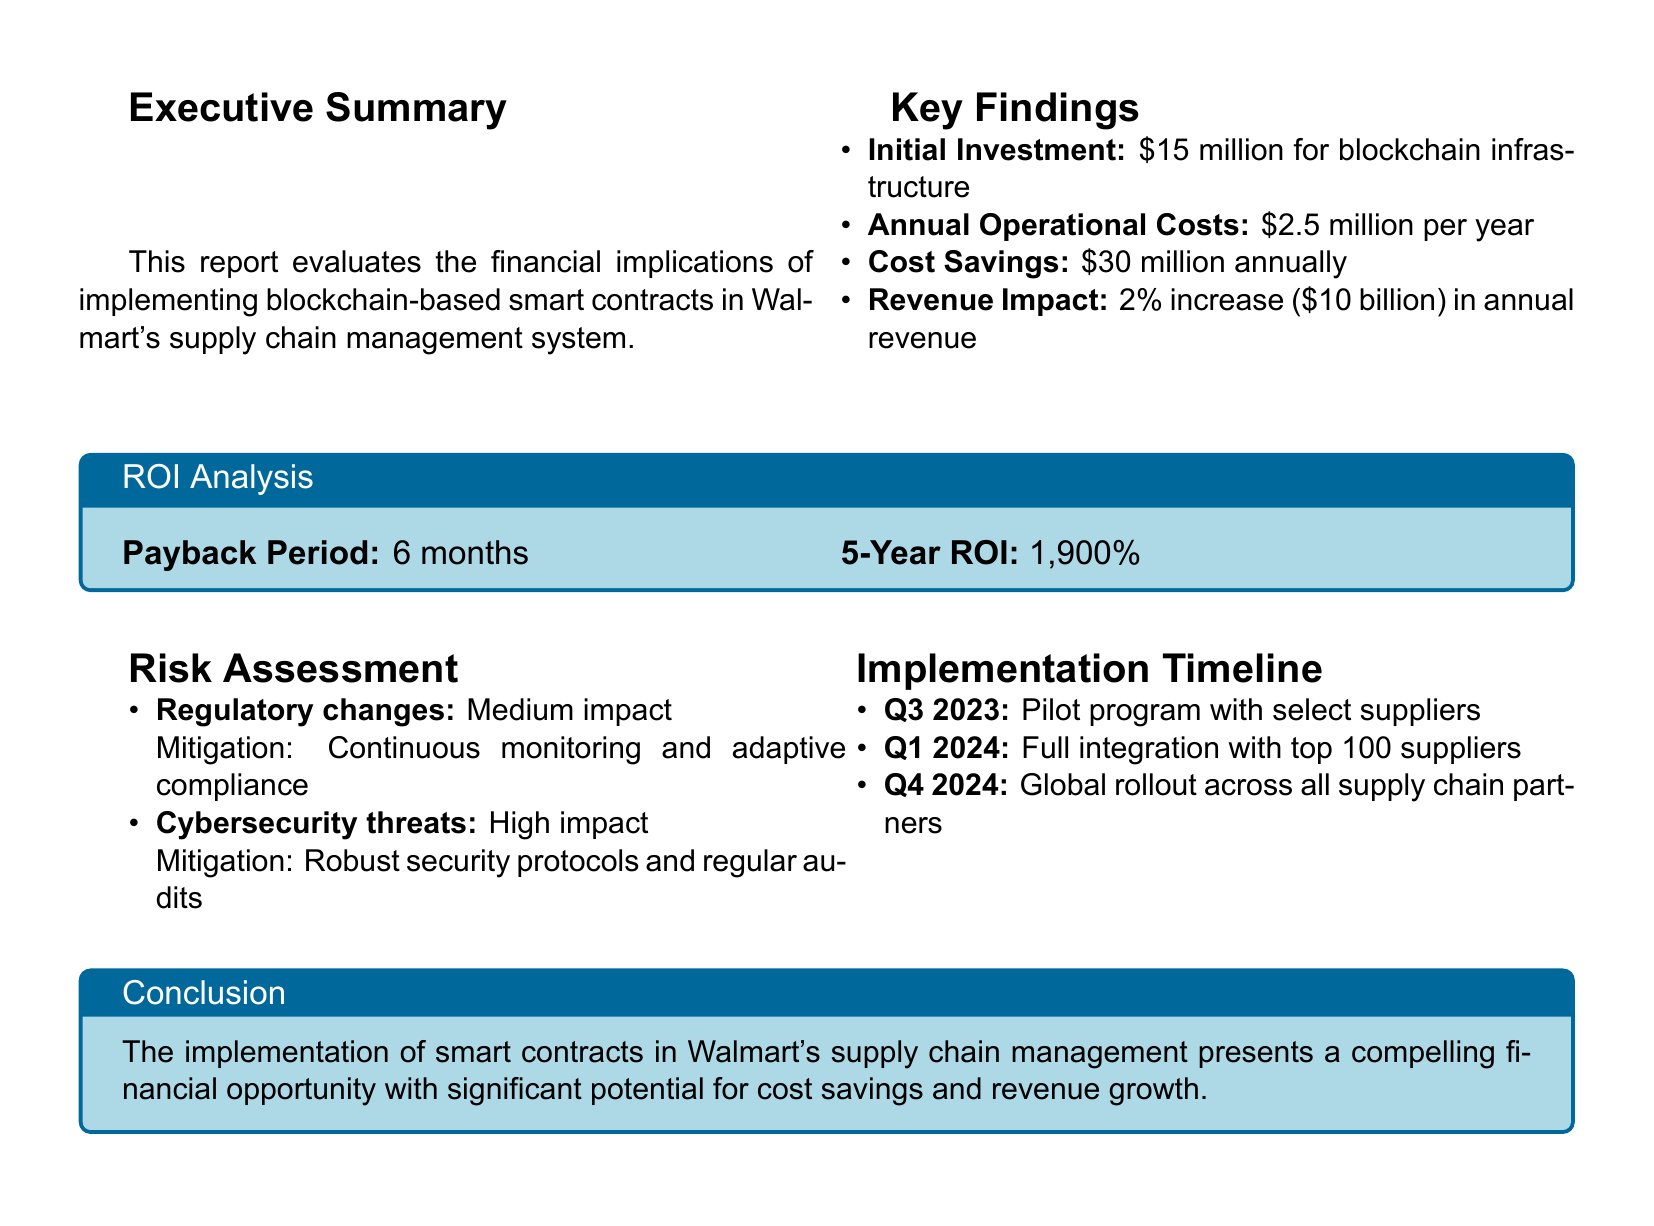What is the title of the report? The title is specified at the top of the document.
Answer: Financial Assessment: Smart Contract Implementation in Supply Chain Management for Walmart What is the estimated initial investment for blockchain implementation? The estimated initial investment is detailed in the key findings section.
Answer: $15 million What are the projected annual operational costs? The operational costs are noted in the key findings section of the report.
Answer: $2.5 million per year What is the anticipated annual cost savings? The cost savings figure is outlined in the key findings.
Answer: $30 million What is the payback period for the investment? The payback period is included in the ROI analysis section.
Answer: 6 months What is the potential increase in annual revenue? The revenue impact is discussed in the key findings and is expressed as a percentage of total revenue.
Answer: 2% What risk has a high impact in the risk assessment? The high-impact risk is listed in the risk assessment section.
Answer: Cybersecurity threats What is the implementation phase planned for Q1 2024? The timeline specifies the activities planned for that quarter in the implementation timeline section.
Answer: Full integration with top 100 suppliers What significant benefit is mentioned in the conclusion? The conclusion summarizes the benefits of implementing smart contracts in the supply chain.
Answer: Significant potential for cost savings and revenue growth 